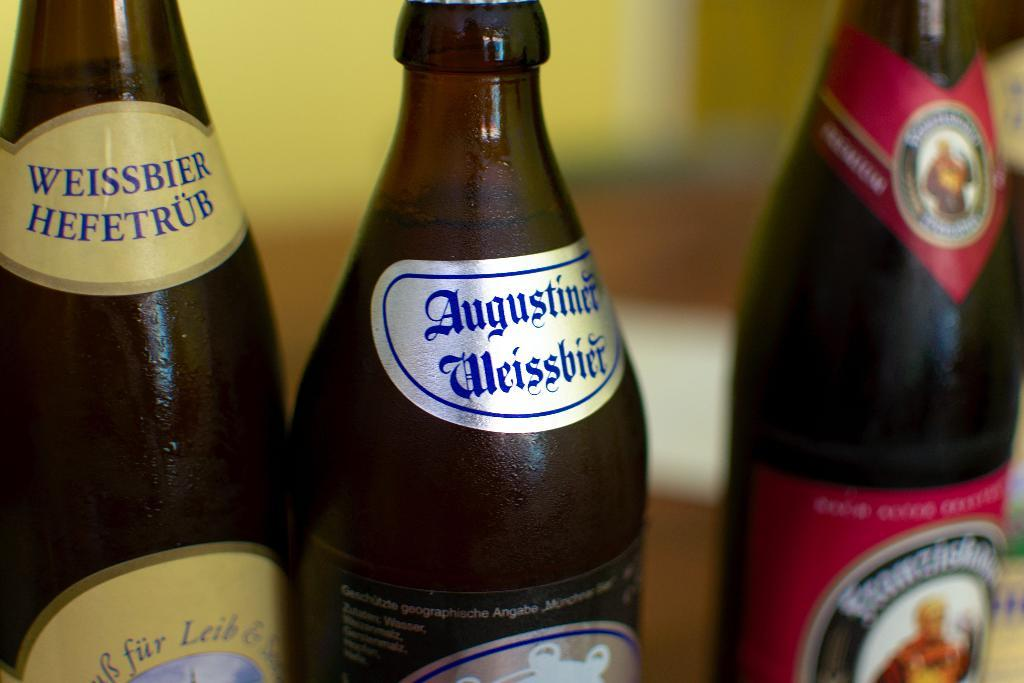<image>
Render a clear and concise summary of the photo. 3 beer bottles, including Weissbier Heftrub, Augustiner Weissbier 